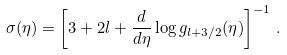Convert formula to latex. <formula><loc_0><loc_0><loc_500><loc_500>\sigma ( \eta ) = \left [ 3 + 2 l + \frac { d } { d \eta } \log g _ { l + 3 / 2 } ( \eta ) \right ] ^ { - 1 } \, .</formula> 